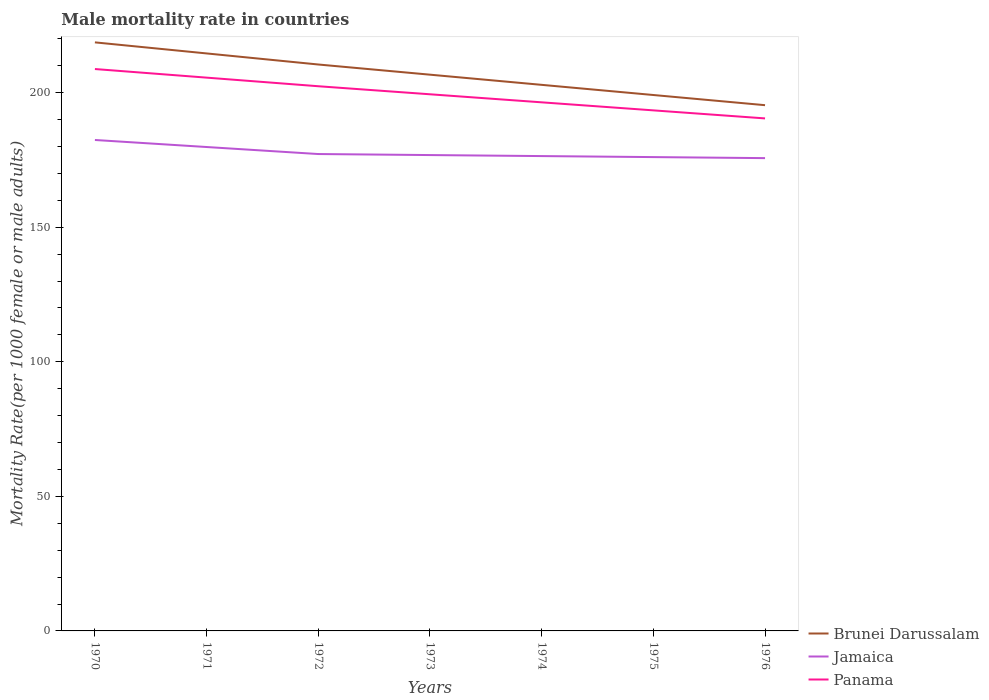Does the line corresponding to Brunei Darussalam intersect with the line corresponding to Panama?
Keep it short and to the point. No. Is the number of lines equal to the number of legend labels?
Provide a short and direct response. Yes. Across all years, what is the maximum male mortality rate in Brunei Darussalam?
Your answer should be very brief. 195.37. In which year was the male mortality rate in Jamaica maximum?
Ensure brevity in your answer.  1976. What is the total male mortality rate in Jamaica in the graph?
Provide a short and direct response. 0.76. What is the difference between the highest and the second highest male mortality rate in Jamaica?
Offer a terse response. 6.74. How many lines are there?
Keep it short and to the point. 3. How many years are there in the graph?
Your answer should be very brief. 7. Does the graph contain any zero values?
Provide a short and direct response. No. Where does the legend appear in the graph?
Ensure brevity in your answer.  Bottom right. How many legend labels are there?
Your answer should be compact. 3. What is the title of the graph?
Make the answer very short. Male mortality rate in countries. What is the label or title of the Y-axis?
Give a very brief answer. Mortality Rate(per 1000 female or male adults). What is the Mortality Rate(per 1000 female or male adults) in Brunei Darussalam in 1970?
Give a very brief answer. 218.71. What is the Mortality Rate(per 1000 female or male adults) of Jamaica in 1970?
Give a very brief answer. 182.43. What is the Mortality Rate(per 1000 female or male adults) in Panama in 1970?
Keep it short and to the point. 208.8. What is the Mortality Rate(per 1000 female or male adults) of Brunei Darussalam in 1971?
Make the answer very short. 214.6. What is the Mortality Rate(per 1000 female or male adults) of Jamaica in 1971?
Make the answer very short. 179.82. What is the Mortality Rate(per 1000 female or male adults) in Panama in 1971?
Your answer should be very brief. 205.6. What is the Mortality Rate(per 1000 female or male adults) of Brunei Darussalam in 1972?
Your response must be concise. 210.48. What is the Mortality Rate(per 1000 female or male adults) in Jamaica in 1972?
Offer a very short reply. 177.21. What is the Mortality Rate(per 1000 female or male adults) in Panama in 1972?
Ensure brevity in your answer.  202.41. What is the Mortality Rate(per 1000 female or male adults) of Brunei Darussalam in 1973?
Provide a succinct answer. 206.71. What is the Mortality Rate(per 1000 female or male adults) in Jamaica in 1973?
Offer a very short reply. 176.83. What is the Mortality Rate(per 1000 female or male adults) in Panama in 1973?
Your answer should be very brief. 199.42. What is the Mortality Rate(per 1000 female or male adults) in Brunei Darussalam in 1974?
Make the answer very short. 202.93. What is the Mortality Rate(per 1000 female or male adults) of Jamaica in 1974?
Offer a very short reply. 176.45. What is the Mortality Rate(per 1000 female or male adults) in Panama in 1974?
Offer a terse response. 196.43. What is the Mortality Rate(per 1000 female or male adults) of Brunei Darussalam in 1975?
Make the answer very short. 199.15. What is the Mortality Rate(per 1000 female or male adults) in Jamaica in 1975?
Provide a succinct answer. 176.07. What is the Mortality Rate(per 1000 female or male adults) in Panama in 1975?
Ensure brevity in your answer.  193.44. What is the Mortality Rate(per 1000 female or male adults) in Brunei Darussalam in 1976?
Keep it short and to the point. 195.37. What is the Mortality Rate(per 1000 female or male adults) of Jamaica in 1976?
Give a very brief answer. 175.7. What is the Mortality Rate(per 1000 female or male adults) of Panama in 1976?
Offer a very short reply. 190.45. Across all years, what is the maximum Mortality Rate(per 1000 female or male adults) of Brunei Darussalam?
Offer a very short reply. 218.71. Across all years, what is the maximum Mortality Rate(per 1000 female or male adults) of Jamaica?
Give a very brief answer. 182.43. Across all years, what is the maximum Mortality Rate(per 1000 female or male adults) in Panama?
Provide a succinct answer. 208.8. Across all years, what is the minimum Mortality Rate(per 1000 female or male adults) of Brunei Darussalam?
Give a very brief answer. 195.37. Across all years, what is the minimum Mortality Rate(per 1000 female or male adults) in Jamaica?
Provide a succinct answer. 175.7. Across all years, what is the minimum Mortality Rate(per 1000 female or male adults) of Panama?
Give a very brief answer. 190.45. What is the total Mortality Rate(per 1000 female or male adults) in Brunei Darussalam in the graph?
Your answer should be compact. 1447.94. What is the total Mortality Rate(per 1000 female or male adults) in Jamaica in the graph?
Make the answer very short. 1244.53. What is the total Mortality Rate(per 1000 female or male adults) of Panama in the graph?
Offer a very short reply. 1396.55. What is the difference between the Mortality Rate(per 1000 female or male adults) of Brunei Darussalam in 1970 and that in 1971?
Your answer should be very brief. 4.11. What is the difference between the Mortality Rate(per 1000 female or male adults) in Jamaica in 1970 and that in 1971?
Provide a short and direct response. 2.61. What is the difference between the Mortality Rate(per 1000 female or male adults) of Panama in 1970 and that in 1971?
Your response must be concise. 3.2. What is the difference between the Mortality Rate(per 1000 female or male adults) in Brunei Darussalam in 1970 and that in 1972?
Provide a succinct answer. 8.23. What is the difference between the Mortality Rate(per 1000 female or male adults) of Jamaica in 1970 and that in 1972?
Keep it short and to the point. 5.22. What is the difference between the Mortality Rate(per 1000 female or male adults) of Panama in 1970 and that in 1972?
Offer a very short reply. 6.39. What is the difference between the Mortality Rate(per 1000 female or male adults) of Brunei Darussalam in 1970 and that in 1973?
Give a very brief answer. 12.01. What is the difference between the Mortality Rate(per 1000 female or male adults) in Jamaica in 1970 and that in 1973?
Provide a short and direct response. 5.6. What is the difference between the Mortality Rate(per 1000 female or male adults) of Panama in 1970 and that in 1973?
Offer a very short reply. 9.38. What is the difference between the Mortality Rate(per 1000 female or male adults) of Brunei Darussalam in 1970 and that in 1974?
Your answer should be compact. 15.79. What is the difference between the Mortality Rate(per 1000 female or male adults) in Jamaica in 1970 and that in 1974?
Keep it short and to the point. 5.98. What is the difference between the Mortality Rate(per 1000 female or male adults) in Panama in 1970 and that in 1974?
Your answer should be very brief. 12.37. What is the difference between the Mortality Rate(per 1000 female or male adults) of Brunei Darussalam in 1970 and that in 1975?
Give a very brief answer. 19.56. What is the difference between the Mortality Rate(per 1000 female or male adults) in Jamaica in 1970 and that in 1975?
Ensure brevity in your answer.  6.36. What is the difference between the Mortality Rate(per 1000 female or male adults) in Panama in 1970 and that in 1975?
Ensure brevity in your answer.  15.36. What is the difference between the Mortality Rate(per 1000 female or male adults) of Brunei Darussalam in 1970 and that in 1976?
Offer a very short reply. 23.34. What is the difference between the Mortality Rate(per 1000 female or male adults) of Jamaica in 1970 and that in 1976?
Your response must be concise. 6.74. What is the difference between the Mortality Rate(per 1000 female or male adults) in Panama in 1970 and that in 1976?
Make the answer very short. 18.35. What is the difference between the Mortality Rate(per 1000 female or male adults) in Brunei Darussalam in 1971 and that in 1972?
Provide a succinct answer. 4.11. What is the difference between the Mortality Rate(per 1000 female or male adults) in Jamaica in 1971 and that in 1972?
Your answer should be compact. 2.61. What is the difference between the Mortality Rate(per 1000 female or male adults) of Panama in 1971 and that in 1972?
Make the answer very short. 3.2. What is the difference between the Mortality Rate(per 1000 female or male adults) in Brunei Darussalam in 1971 and that in 1973?
Make the answer very short. 7.89. What is the difference between the Mortality Rate(per 1000 female or male adults) in Jamaica in 1971 and that in 1973?
Your answer should be very brief. 2.99. What is the difference between the Mortality Rate(per 1000 female or male adults) of Panama in 1971 and that in 1973?
Ensure brevity in your answer.  6.19. What is the difference between the Mortality Rate(per 1000 female or male adults) in Brunei Darussalam in 1971 and that in 1974?
Provide a short and direct response. 11.67. What is the difference between the Mortality Rate(per 1000 female or male adults) in Jamaica in 1971 and that in 1974?
Give a very brief answer. 3.37. What is the difference between the Mortality Rate(per 1000 female or male adults) in Panama in 1971 and that in 1974?
Offer a terse response. 9.18. What is the difference between the Mortality Rate(per 1000 female or male adults) of Brunei Darussalam in 1971 and that in 1975?
Your answer should be very brief. 15.45. What is the difference between the Mortality Rate(per 1000 female or male adults) in Jamaica in 1971 and that in 1975?
Offer a terse response. 3.75. What is the difference between the Mortality Rate(per 1000 female or male adults) in Panama in 1971 and that in 1975?
Your response must be concise. 12.16. What is the difference between the Mortality Rate(per 1000 female or male adults) of Brunei Darussalam in 1971 and that in 1976?
Provide a succinct answer. 19.23. What is the difference between the Mortality Rate(per 1000 female or male adults) in Jamaica in 1971 and that in 1976?
Ensure brevity in your answer.  4.13. What is the difference between the Mortality Rate(per 1000 female or male adults) in Panama in 1971 and that in 1976?
Your answer should be compact. 15.15. What is the difference between the Mortality Rate(per 1000 female or male adults) in Brunei Darussalam in 1972 and that in 1973?
Offer a very short reply. 3.78. What is the difference between the Mortality Rate(per 1000 female or male adults) in Jamaica in 1972 and that in 1973?
Provide a short and direct response. 0.38. What is the difference between the Mortality Rate(per 1000 female or male adults) in Panama in 1972 and that in 1973?
Your response must be concise. 2.99. What is the difference between the Mortality Rate(per 1000 female or male adults) in Brunei Darussalam in 1972 and that in 1974?
Offer a very short reply. 7.56. What is the difference between the Mortality Rate(per 1000 female or male adults) of Jamaica in 1972 and that in 1974?
Offer a terse response. 0.76. What is the difference between the Mortality Rate(per 1000 female or male adults) in Panama in 1972 and that in 1974?
Offer a very short reply. 5.98. What is the difference between the Mortality Rate(per 1000 female or male adults) in Brunei Darussalam in 1972 and that in 1975?
Offer a terse response. 11.34. What is the difference between the Mortality Rate(per 1000 female or male adults) in Jamaica in 1972 and that in 1975?
Keep it short and to the point. 1.14. What is the difference between the Mortality Rate(per 1000 female or male adults) of Panama in 1972 and that in 1975?
Ensure brevity in your answer.  8.97. What is the difference between the Mortality Rate(per 1000 female or male adults) of Brunei Darussalam in 1972 and that in 1976?
Make the answer very short. 15.12. What is the difference between the Mortality Rate(per 1000 female or male adults) in Jamaica in 1972 and that in 1976?
Ensure brevity in your answer.  1.52. What is the difference between the Mortality Rate(per 1000 female or male adults) of Panama in 1972 and that in 1976?
Provide a short and direct response. 11.96. What is the difference between the Mortality Rate(per 1000 female or male adults) of Brunei Darussalam in 1973 and that in 1974?
Provide a succinct answer. 3.78. What is the difference between the Mortality Rate(per 1000 female or male adults) of Jamaica in 1973 and that in 1974?
Give a very brief answer. 0.38. What is the difference between the Mortality Rate(per 1000 female or male adults) in Panama in 1973 and that in 1974?
Your answer should be compact. 2.99. What is the difference between the Mortality Rate(per 1000 female or male adults) in Brunei Darussalam in 1973 and that in 1975?
Give a very brief answer. 7.56. What is the difference between the Mortality Rate(per 1000 female or male adults) in Jamaica in 1973 and that in 1975?
Your answer should be very brief. 0.76. What is the difference between the Mortality Rate(per 1000 female or male adults) in Panama in 1973 and that in 1975?
Give a very brief answer. 5.98. What is the difference between the Mortality Rate(per 1000 female or male adults) in Brunei Darussalam in 1973 and that in 1976?
Your answer should be compact. 11.34. What is the difference between the Mortality Rate(per 1000 female or male adults) of Jamaica in 1973 and that in 1976?
Provide a succinct answer. 1.14. What is the difference between the Mortality Rate(per 1000 female or male adults) in Panama in 1973 and that in 1976?
Provide a short and direct response. 8.97. What is the difference between the Mortality Rate(per 1000 female or male adults) in Brunei Darussalam in 1974 and that in 1975?
Offer a terse response. 3.78. What is the difference between the Mortality Rate(per 1000 female or male adults) of Jamaica in 1974 and that in 1975?
Offer a very short reply. 0.38. What is the difference between the Mortality Rate(per 1000 female or male adults) of Panama in 1974 and that in 1975?
Provide a short and direct response. 2.99. What is the difference between the Mortality Rate(per 1000 female or male adults) of Brunei Darussalam in 1974 and that in 1976?
Your answer should be very brief. 7.56. What is the difference between the Mortality Rate(per 1000 female or male adults) in Jamaica in 1974 and that in 1976?
Your answer should be very brief. 0.76. What is the difference between the Mortality Rate(per 1000 female or male adults) in Panama in 1974 and that in 1976?
Offer a very short reply. 5.98. What is the difference between the Mortality Rate(per 1000 female or male adults) in Brunei Darussalam in 1975 and that in 1976?
Give a very brief answer. 3.78. What is the difference between the Mortality Rate(per 1000 female or male adults) in Jamaica in 1975 and that in 1976?
Keep it short and to the point. 0.38. What is the difference between the Mortality Rate(per 1000 female or male adults) in Panama in 1975 and that in 1976?
Ensure brevity in your answer.  2.99. What is the difference between the Mortality Rate(per 1000 female or male adults) of Brunei Darussalam in 1970 and the Mortality Rate(per 1000 female or male adults) of Jamaica in 1971?
Offer a terse response. 38.89. What is the difference between the Mortality Rate(per 1000 female or male adults) in Brunei Darussalam in 1970 and the Mortality Rate(per 1000 female or male adults) in Panama in 1971?
Ensure brevity in your answer.  13.11. What is the difference between the Mortality Rate(per 1000 female or male adults) of Jamaica in 1970 and the Mortality Rate(per 1000 female or male adults) of Panama in 1971?
Give a very brief answer. -23.17. What is the difference between the Mortality Rate(per 1000 female or male adults) of Brunei Darussalam in 1970 and the Mortality Rate(per 1000 female or male adults) of Jamaica in 1972?
Give a very brief answer. 41.5. What is the difference between the Mortality Rate(per 1000 female or male adults) of Brunei Darussalam in 1970 and the Mortality Rate(per 1000 female or male adults) of Panama in 1972?
Provide a short and direct response. 16.3. What is the difference between the Mortality Rate(per 1000 female or male adults) in Jamaica in 1970 and the Mortality Rate(per 1000 female or male adults) in Panama in 1972?
Your answer should be compact. -19.97. What is the difference between the Mortality Rate(per 1000 female or male adults) of Brunei Darussalam in 1970 and the Mortality Rate(per 1000 female or male adults) of Jamaica in 1973?
Provide a short and direct response. 41.88. What is the difference between the Mortality Rate(per 1000 female or male adults) of Brunei Darussalam in 1970 and the Mortality Rate(per 1000 female or male adults) of Panama in 1973?
Ensure brevity in your answer.  19.29. What is the difference between the Mortality Rate(per 1000 female or male adults) in Jamaica in 1970 and the Mortality Rate(per 1000 female or male adults) in Panama in 1973?
Offer a very short reply. -16.98. What is the difference between the Mortality Rate(per 1000 female or male adults) in Brunei Darussalam in 1970 and the Mortality Rate(per 1000 female or male adults) in Jamaica in 1974?
Keep it short and to the point. 42.26. What is the difference between the Mortality Rate(per 1000 female or male adults) in Brunei Darussalam in 1970 and the Mortality Rate(per 1000 female or male adults) in Panama in 1974?
Provide a succinct answer. 22.28. What is the difference between the Mortality Rate(per 1000 female or male adults) in Jamaica in 1970 and the Mortality Rate(per 1000 female or male adults) in Panama in 1974?
Keep it short and to the point. -13.99. What is the difference between the Mortality Rate(per 1000 female or male adults) of Brunei Darussalam in 1970 and the Mortality Rate(per 1000 female or male adults) of Jamaica in 1975?
Your response must be concise. 42.64. What is the difference between the Mortality Rate(per 1000 female or male adults) in Brunei Darussalam in 1970 and the Mortality Rate(per 1000 female or male adults) in Panama in 1975?
Your answer should be very brief. 25.27. What is the difference between the Mortality Rate(per 1000 female or male adults) of Jamaica in 1970 and the Mortality Rate(per 1000 female or male adults) of Panama in 1975?
Make the answer very short. -11.01. What is the difference between the Mortality Rate(per 1000 female or male adults) of Brunei Darussalam in 1970 and the Mortality Rate(per 1000 female or male adults) of Jamaica in 1976?
Make the answer very short. 43.02. What is the difference between the Mortality Rate(per 1000 female or male adults) in Brunei Darussalam in 1970 and the Mortality Rate(per 1000 female or male adults) in Panama in 1976?
Your response must be concise. 28.26. What is the difference between the Mortality Rate(per 1000 female or male adults) in Jamaica in 1970 and the Mortality Rate(per 1000 female or male adults) in Panama in 1976?
Provide a succinct answer. -8.02. What is the difference between the Mortality Rate(per 1000 female or male adults) in Brunei Darussalam in 1971 and the Mortality Rate(per 1000 female or male adults) in Jamaica in 1972?
Your answer should be compact. 37.39. What is the difference between the Mortality Rate(per 1000 female or male adults) of Brunei Darussalam in 1971 and the Mortality Rate(per 1000 female or male adults) of Panama in 1972?
Your answer should be very brief. 12.19. What is the difference between the Mortality Rate(per 1000 female or male adults) in Jamaica in 1971 and the Mortality Rate(per 1000 female or male adults) in Panama in 1972?
Provide a short and direct response. -22.58. What is the difference between the Mortality Rate(per 1000 female or male adults) of Brunei Darussalam in 1971 and the Mortality Rate(per 1000 female or male adults) of Jamaica in 1973?
Keep it short and to the point. 37.77. What is the difference between the Mortality Rate(per 1000 female or male adults) in Brunei Darussalam in 1971 and the Mortality Rate(per 1000 female or male adults) in Panama in 1973?
Make the answer very short. 15.18. What is the difference between the Mortality Rate(per 1000 female or male adults) in Jamaica in 1971 and the Mortality Rate(per 1000 female or male adults) in Panama in 1973?
Keep it short and to the point. -19.59. What is the difference between the Mortality Rate(per 1000 female or male adults) of Brunei Darussalam in 1971 and the Mortality Rate(per 1000 female or male adults) of Jamaica in 1974?
Your answer should be very brief. 38.14. What is the difference between the Mortality Rate(per 1000 female or male adults) of Brunei Darussalam in 1971 and the Mortality Rate(per 1000 female or male adults) of Panama in 1974?
Provide a succinct answer. 18.17. What is the difference between the Mortality Rate(per 1000 female or male adults) in Jamaica in 1971 and the Mortality Rate(per 1000 female or male adults) in Panama in 1974?
Your answer should be compact. -16.61. What is the difference between the Mortality Rate(per 1000 female or male adults) in Brunei Darussalam in 1971 and the Mortality Rate(per 1000 female or male adults) in Jamaica in 1975?
Offer a very short reply. 38.52. What is the difference between the Mortality Rate(per 1000 female or male adults) in Brunei Darussalam in 1971 and the Mortality Rate(per 1000 female or male adults) in Panama in 1975?
Offer a very short reply. 21.16. What is the difference between the Mortality Rate(per 1000 female or male adults) in Jamaica in 1971 and the Mortality Rate(per 1000 female or male adults) in Panama in 1975?
Provide a short and direct response. -13.62. What is the difference between the Mortality Rate(per 1000 female or male adults) in Brunei Darussalam in 1971 and the Mortality Rate(per 1000 female or male adults) in Jamaica in 1976?
Ensure brevity in your answer.  38.9. What is the difference between the Mortality Rate(per 1000 female or male adults) of Brunei Darussalam in 1971 and the Mortality Rate(per 1000 female or male adults) of Panama in 1976?
Provide a short and direct response. 24.15. What is the difference between the Mortality Rate(per 1000 female or male adults) in Jamaica in 1971 and the Mortality Rate(per 1000 female or male adults) in Panama in 1976?
Make the answer very short. -10.63. What is the difference between the Mortality Rate(per 1000 female or male adults) in Brunei Darussalam in 1972 and the Mortality Rate(per 1000 female or male adults) in Jamaica in 1973?
Offer a very short reply. 33.65. What is the difference between the Mortality Rate(per 1000 female or male adults) in Brunei Darussalam in 1972 and the Mortality Rate(per 1000 female or male adults) in Panama in 1973?
Provide a short and direct response. 11.07. What is the difference between the Mortality Rate(per 1000 female or male adults) in Jamaica in 1972 and the Mortality Rate(per 1000 female or male adults) in Panama in 1973?
Offer a very short reply. -22.21. What is the difference between the Mortality Rate(per 1000 female or male adults) in Brunei Darussalam in 1972 and the Mortality Rate(per 1000 female or male adults) in Jamaica in 1974?
Provide a short and direct response. 34.03. What is the difference between the Mortality Rate(per 1000 female or male adults) of Brunei Darussalam in 1972 and the Mortality Rate(per 1000 female or male adults) of Panama in 1974?
Ensure brevity in your answer.  14.05. What is the difference between the Mortality Rate(per 1000 female or male adults) of Jamaica in 1972 and the Mortality Rate(per 1000 female or male adults) of Panama in 1974?
Give a very brief answer. -19.22. What is the difference between the Mortality Rate(per 1000 female or male adults) of Brunei Darussalam in 1972 and the Mortality Rate(per 1000 female or male adults) of Jamaica in 1975?
Your response must be concise. 34.41. What is the difference between the Mortality Rate(per 1000 female or male adults) in Brunei Darussalam in 1972 and the Mortality Rate(per 1000 female or male adults) in Panama in 1975?
Make the answer very short. 17.04. What is the difference between the Mortality Rate(per 1000 female or male adults) in Jamaica in 1972 and the Mortality Rate(per 1000 female or male adults) in Panama in 1975?
Provide a succinct answer. -16.23. What is the difference between the Mortality Rate(per 1000 female or male adults) of Brunei Darussalam in 1972 and the Mortality Rate(per 1000 female or male adults) of Jamaica in 1976?
Provide a short and direct response. 34.79. What is the difference between the Mortality Rate(per 1000 female or male adults) of Brunei Darussalam in 1972 and the Mortality Rate(per 1000 female or male adults) of Panama in 1976?
Offer a very short reply. 20.03. What is the difference between the Mortality Rate(per 1000 female or male adults) in Jamaica in 1972 and the Mortality Rate(per 1000 female or male adults) in Panama in 1976?
Ensure brevity in your answer.  -13.24. What is the difference between the Mortality Rate(per 1000 female or male adults) in Brunei Darussalam in 1973 and the Mortality Rate(per 1000 female or male adults) in Jamaica in 1974?
Your response must be concise. 30.25. What is the difference between the Mortality Rate(per 1000 female or male adults) of Brunei Darussalam in 1973 and the Mortality Rate(per 1000 female or male adults) of Panama in 1974?
Make the answer very short. 10.28. What is the difference between the Mortality Rate(per 1000 female or male adults) in Jamaica in 1973 and the Mortality Rate(per 1000 female or male adults) in Panama in 1974?
Provide a succinct answer. -19.6. What is the difference between the Mortality Rate(per 1000 female or male adults) of Brunei Darussalam in 1973 and the Mortality Rate(per 1000 female or male adults) of Jamaica in 1975?
Your response must be concise. 30.63. What is the difference between the Mortality Rate(per 1000 female or male adults) of Brunei Darussalam in 1973 and the Mortality Rate(per 1000 female or male adults) of Panama in 1975?
Provide a succinct answer. 13.27. What is the difference between the Mortality Rate(per 1000 female or male adults) in Jamaica in 1973 and the Mortality Rate(per 1000 female or male adults) in Panama in 1975?
Provide a short and direct response. -16.61. What is the difference between the Mortality Rate(per 1000 female or male adults) in Brunei Darussalam in 1973 and the Mortality Rate(per 1000 female or male adults) in Jamaica in 1976?
Your answer should be very brief. 31.01. What is the difference between the Mortality Rate(per 1000 female or male adults) in Brunei Darussalam in 1973 and the Mortality Rate(per 1000 female or male adults) in Panama in 1976?
Your response must be concise. 16.25. What is the difference between the Mortality Rate(per 1000 female or male adults) in Jamaica in 1973 and the Mortality Rate(per 1000 female or male adults) in Panama in 1976?
Provide a short and direct response. -13.62. What is the difference between the Mortality Rate(per 1000 female or male adults) of Brunei Darussalam in 1974 and the Mortality Rate(per 1000 female or male adults) of Jamaica in 1975?
Your response must be concise. 26.85. What is the difference between the Mortality Rate(per 1000 female or male adults) in Brunei Darussalam in 1974 and the Mortality Rate(per 1000 female or male adults) in Panama in 1975?
Ensure brevity in your answer.  9.49. What is the difference between the Mortality Rate(per 1000 female or male adults) of Jamaica in 1974 and the Mortality Rate(per 1000 female or male adults) of Panama in 1975?
Your response must be concise. -16.99. What is the difference between the Mortality Rate(per 1000 female or male adults) of Brunei Darussalam in 1974 and the Mortality Rate(per 1000 female or male adults) of Jamaica in 1976?
Give a very brief answer. 27.23. What is the difference between the Mortality Rate(per 1000 female or male adults) in Brunei Darussalam in 1974 and the Mortality Rate(per 1000 female or male adults) in Panama in 1976?
Offer a terse response. 12.47. What is the difference between the Mortality Rate(per 1000 female or male adults) in Jamaica in 1974 and the Mortality Rate(per 1000 female or male adults) in Panama in 1976?
Provide a short and direct response. -14. What is the difference between the Mortality Rate(per 1000 female or male adults) of Brunei Darussalam in 1975 and the Mortality Rate(per 1000 female or male adults) of Jamaica in 1976?
Make the answer very short. 23.45. What is the difference between the Mortality Rate(per 1000 female or male adults) of Brunei Darussalam in 1975 and the Mortality Rate(per 1000 female or male adults) of Panama in 1976?
Your answer should be compact. 8.7. What is the difference between the Mortality Rate(per 1000 female or male adults) of Jamaica in 1975 and the Mortality Rate(per 1000 female or male adults) of Panama in 1976?
Offer a very short reply. -14.38. What is the average Mortality Rate(per 1000 female or male adults) in Brunei Darussalam per year?
Your answer should be compact. 206.85. What is the average Mortality Rate(per 1000 female or male adults) in Jamaica per year?
Make the answer very short. 177.79. What is the average Mortality Rate(per 1000 female or male adults) of Panama per year?
Provide a succinct answer. 199.51. In the year 1970, what is the difference between the Mortality Rate(per 1000 female or male adults) in Brunei Darussalam and Mortality Rate(per 1000 female or male adults) in Jamaica?
Your answer should be compact. 36.28. In the year 1970, what is the difference between the Mortality Rate(per 1000 female or male adults) in Brunei Darussalam and Mortality Rate(per 1000 female or male adults) in Panama?
Your answer should be compact. 9.91. In the year 1970, what is the difference between the Mortality Rate(per 1000 female or male adults) in Jamaica and Mortality Rate(per 1000 female or male adults) in Panama?
Make the answer very short. -26.37. In the year 1971, what is the difference between the Mortality Rate(per 1000 female or male adults) of Brunei Darussalam and Mortality Rate(per 1000 female or male adults) of Jamaica?
Offer a very short reply. 34.77. In the year 1971, what is the difference between the Mortality Rate(per 1000 female or male adults) of Brunei Darussalam and Mortality Rate(per 1000 female or male adults) of Panama?
Ensure brevity in your answer.  8.99. In the year 1971, what is the difference between the Mortality Rate(per 1000 female or male adults) of Jamaica and Mortality Rate(per 1000 female or male adults) of Panama?
Offer a very short reply. -25.78. In the year 1972, what is the difference between the Mortality Rate(per 1000 female or male adults) of Brunei Darussalam and Mortality Rate(per 1000 female or male adults) of Jamaica?
Offer a terse response. 33.27. In the year 1972, what is the difference between the Mortality Rate(per 1000 female or male adults) in Brunei Darussalam and Mortality Rate(per 1000 female or male adults) in Panama?
Your response must be concise. 8.08. In the year 1972, what is the difference between the Mortality Rate(per 1000 female or male adults) of Jamaica and Mortality Rate(per 1000 female or male adults) of Panama?
Offer a terse response. -25.2. In the year 1973, what is the difference between the Mortality Rate(per 1000 female or male adults) of Brunei Darussalam and Mortality Rate(per 1000 female or male adults) of Jamaica?
Your answer should be very brief. 29.87. In the year 1973, what is the difference between the Mortality Rate(per 1000 female or male adults) in Brunei Darussalam and Mortality Rate(per 1000 female or male adults) in Panama?
Provide a short and direct response. 7.29. In the year 1973, what is the difference between the Mortality Rate(per 1000 female or male adults) in Jamaica and Mortality Rate(per 1000 female or male adults) in Panama?
Make the answer very short. -22.59. In the year 1974, what is the difference between the Mortality Rate(per 1000 female or male adults) in Brunei Darussalam and Mortality Rate(per 1000 female or male adults) in Jamaica?
Give a very brief answer. 26.47. In the year 1974, what is the difference between the Mortality Rate(per 1000 female or male adults) of Brunei Darussalam and Mortality Rate(per 1000 female or male adults) of Panama?
Make the answer very short. 6.5. In the year 1974, what is the difference between the Mortality Rate(per 1000 female or male adults) in Jamaica and Mortality Rate(per 1000 female or male adults) in Panama?
Give a very brief answer. -19.98. In the year 1975, what is the difference between the Mortality Rate(per 1000 female or male adults) in Brunei Darussalam and Mortality Rate(per 1000 female or male adults) in Jamaica?
Make the answer very short. 23.07. In the year 1975, what is the difference between the Mortality Rate(per 1000 female or male adults) of Brunei Darussalam and Mortality Rate(per 1000 female or male adults) of Panama?
Provide a succinct answer. 5.71. In the year 1975, what is the difference between the Mortality Rate(per 1000 female or male adults) in Jamaica and Mortality Rate(per 1000 female or male adults) in Panama?
Make the answer very short. -17.37. In the year 1976, what is the difference between the Mortality Rate(per 1000 female or male adults) in Brunei Darussalam and Mortality Rate(per 1000 female or male adults) in Jamaica?
Give a very brief answer. 19.67. In the year 1976, what is the difference between the Mortality Rate(per 1000 female or male adults) of Brunei Darussalam and Mortality Rate(per 1000 female or male adults) of Panama?
Provide a short and direct response. 4.92. In the year 1976, what is the difference between the Mortality Rate(per 1000 female or male adults) of Jamaica and Mortality Rate(per 1000 female or male adults) of Panama?
Your answer should be very brief. -14.76. What is the ratio of the Mortality Rate(per 1000 female or male adults) of Brunei Darussalam in 1970 to that in 1971?
Make the answer very short. 1.02. What is the ratio of the Mortality Rate(per 1000 female or male adults) in Jamaica in 1970 to that in 1971?
Your answer should be very brief. 1.01. What is the ratio of the Mortality Rate(per 1000 female or male adults) in Panama in 1970 to that in 1971?
Your answer should be very brief. 1.02. What is the ratio of the Mortality Rate(per 1000 female or male adults) of Brunei Darussalam in 1970 to that in 1972?
Your answer should be compact. 1.04. What is the ratio of the Mortality Rate(per 1000 female or male adults) in Jamaica in 1970 to that in 1972?
Ensure brevity in your answer.  1.03. What is the ratio of the Mortality Rate(per 1000 female or male adults) in Panama in 1970 to that in 1972?
Make the answer very short. 1.03. What is the ratio of the Mortality Rate(per 1000 female or male adults) of Brunei Darussalam in 1970 to that in 1973?
Provide a succinct answer. 1.06. What is the ratio of the Mortality Rate(per 1000 female or male adults) in Jamaica in 1970 to that in 1973?
Provide a short and direct response. 1.03. What is the ratio of the Mortality Rate(per 1000 female or male adults) in Panama in 1970 to that in 1973?
Make the answer very short. 1.05. What is the ratio of the Mortality Rate(per 1000 female or male adults) in Brunei Darussalam in 1970 to that in 1974?
Make the answer very short. 1.08. What is the ratio of the Mortality Rate(per 1000 female or male adults) in Jamaica in 1970 to that in 1974?
Provide a short and direct response. 1.03. What is the ratio of the Mortality Rate(per 1000 female or male adults) of Panama in 1970 to that in 1974?
Make the answer very short. 1.06. What is the ratio of the Mortality Rate(per 1000 female or male adults) in Brunei Darussalam in 1970 to that in 1975?
Give a very brief answer. 1.1. What is the ratio of the Mortality Rate(per 1000 female or male adults) of Jamaica in 1970 to that in 1975?
Provide a succinct answer. 1.04. What is the ratio of the Mortality Rate(per 1000 female or male adults) of Panama in 1970 to that in 1975?
Your response must be concise. 1.08. What is the ratio of the Mortality Rate(per 1000 female or male adults) of Brunei Darussalam in 1970 to that in 1976?
Make the answer very short. 1.12. What is the ratio of the Mortality Rate(per 1000 female or male adults) of Jamaica in 1970 to that in 1976?
Your answer should be very brief. 1.04. What is the ratio of the Mortality Rate(per 1000 female or male adults) of Panama in 1970 to that in 1976?
Offer a very short reply. 1.1. What is the ratio of the Mortality Rate(per 1000 female or male adults) of Brunei Darussalam in 1971 to that in 1972?
Provide a short and direct response. 1.02. What is the ratio of the Mortality Rate(per 1000 female or male adults) in Jamaica in 1971 to that in 1972?
Your answer should be very brief. 1.01. What is the ratio of the Mortality Rate(per 1000 female or male adults) of Panama in 1971 to that in 1972?
Keep it short and to the point. 1.02. What is the ratio of the Mortality Rate(per 1000 female or male adults) in Brunei Darussalam in 1971 to that in 1973?
Make the answer very short. 1.04. What is the ratio of the Mortality Rate(per 1000 female or male adults) of Jamaica in 1971 to that in 1973?
Your answer should be very brief. 1.02. What is the ratio of the Mortality Rate(per 1000 female or male adults) of Panama in 1971 to that in 1973?
Your answer should be compact. 1.03. What is the ratio of the Mortality Rate(per 1000 female or male adults) in Brunei Darussalam in 1971 to that in 1974?
Offer a terse response. 1.06. What is the ratio of the Mortality Rate(per 1000 female or male adults) of Jamaica in 1971 to that in 1974?
Provide a short and direct response. 1.02. What is the ratio of the Mortality Rate(per 1000 female or male adults) in Panama in 1971 to that in 1974?
Your answer should be very brief. 1.05. What is the ratio of the Mortality Rate(per 1000 female or male adults) in Brunei Darussalam in 1971 to that in 1975?
Offer a very short reply. 1.08. What is the ratio of the Mortality Rate(per 1000 female or male adults) of Jamaica in 1971 to that in 1975?
Your answer should be compact. 1.02. What is the ratio of the Mortality Rate(per 1000 female or male adults) in Panama in 1971 to that in 1975?
Offer a terse response. 1.06. What is the ratio of the Mortality Rate(per 1000 female or male adults) of Brunei Darussalam in 1971 to that in 1976?
Keep it short and to the point. 1.1. What is the ratio of the Mortality Rate(per 1000 female or male adults) in Jamaica in 1971 to that in 1976?
Provide a short and direct response. 1.02. What is the ratio of the Mortality Rate(per 1000 female or male adults) of Panama in 1971 to that in 1976?
Give a very brief answer. 1.08. What is the ratio of the Mortality Rate(per 1000 female or male adults) of Brunei Darussalam in 1972 to that in 1973?
Ensure brevity in your answer.  1.02. What is the ratio of the Mortality Rate(per 1000 female or male adults) in Jamaica in 1972 to that in 1973?
Your answer should be compact. 1. What is the ratio of the Mortality Rate(per 1000 female or male adults) of Panama in 1972 to that in 1973?
Keep it short and to the point. 1.01. What is the ratio of the Mortality Rate(per 1000 female or male adults) in Brunei Darussalam in 1972 to that in 1974?
Give a very brief answer. 1.04. What is the ratio of the Mortality Rate(per 1000 female or male adults) of Panama in 1972 to that in 1974?
Your response must be concise. 1.03. What is the ratio of the Mortality Rate(per 1000 female or male adults) in Brunei Darussalam in 1972 to that in 1975?
Offer a terse response. 1.06. What is the ratio of the Mortality Rate(per 1000 female or male adults) of Panama in 1972 to that in 1975?
Keep it short and to the point. 1.05. What is the ratio of the Mortality Rate(per 1000 female or male adults) of Brunei Darussalam in 1972 to that in 1976?
Provide a succinct answer. 1.08. What is the ratio of the Mortality Rate(per 1000 female or male adults) in Jamaica in 1972 to that in 1976?
Your answer should be very brief. 1.01. What is the ratio of the Mortality Rate(per 1000 female or male adults) of Panama in 1972 to that in 1976?
Offer a terse response. 1.06. What is the ratio of the Mortality Rate(per 1000 female or male adults) in Brunei Darussalam in 1973 to that in 1974?
Provide a short and direct response. 1.02. What is the ratio of the Mortality Rate(per 1000 female or male adults) of Panama in 1973 to that in 1974?
Give a very brief answer. 1.02. What is the ratio of the Mortality Rate(per 1000 female or male adults) in Brunei Darussalam in 1973 to that in 1975?
Ensure brevity in your answer.  1.04. What is the ratio of the Mortality Rate(per 1000 female or male adults) in Jamaica in 1973 to that in 1975?
Give a very brief answer. 1. What is the ratio of the Mortality Rate(per 1000 female or male adults) of Panama in 1973 to that in 1975?
Provide a succinct answer. 1.03. What is the ratio of the Mortality Rate(per 1000 female or male adults) of Brunei Darussalam in 1973 to that in 1976?
Your answer should be compact. 1.06. What is the ratio of the Mortality Rate(per 1000 female or male adults) of Jamaica in 1973 to that in 1976?
Make the answer very short. 1.01. What is the ratio of the Mortality Rate(per 1000 female or male adults) in Panama in 1973 to that in 1976?
Make the answer very short. 1.05. What is the ratio of the Mortality Rate(per 1000 female or male adults) in Brunei Darussalam in 1974 to that in 1975?
Your response must be concise. 1.02. What is the ratio of the Mortality Rate(per 1000 female or male adults) of Panama in 1974 to that in 1975?
Your answer should be very brief. 1.02. What is the ratio of the Mortality Rate(per 1000 female or male adults) in Brunei Darussalam in 1974 to that in 1976?
Keep it short and to the point. 1.04. What is the ratio of the Mortality Rate(per 1000 female or male adults) in Panama in 1974 to that in 1976?
Offer a very short reply. 1.03. What is the ratio of the Mortality Rate(per 1000 female or male adults) of Brunei Darussalam in 1975 to that in 1976?
Give a very brief answer. 1.02. What is the ratio of the Mortality Rate(per 1000 female or male adults) in Panama in 1975 to that in 1976?
Make the answer very short. 1.02. What is the difference between the highest and the second highest Mortality Rate(per 1000 female or male adults) of Brunei Darussalam?
Offer a very short reply. 4.11. What is the difference between the highest and the second highest Mortality Rate(per 1000 female or male adults) in Jamaica?
Ensure brevity in your answer.  2.61. What is the difference between the highest and the second highest Mortality Rate(per 1000 female or male adults) in Panama?
Your answer should be compact. 3.2. What is the difference between the highest and the lowest Mortality Rate(per 1000 female or male adults) of Brunei Darussalam?
Your answer should be compact. 23.34. What is the difference between the highest and the lowest Mortality Rate(per 1000 female or male adults) of Jamaica?
Ensure brevity in your answer.  6.74. What is the difference between the highest and the lowest Mortality Rate(per 1000 female or male adults) in Panama?
Keep it short and to the point. 18.35. 